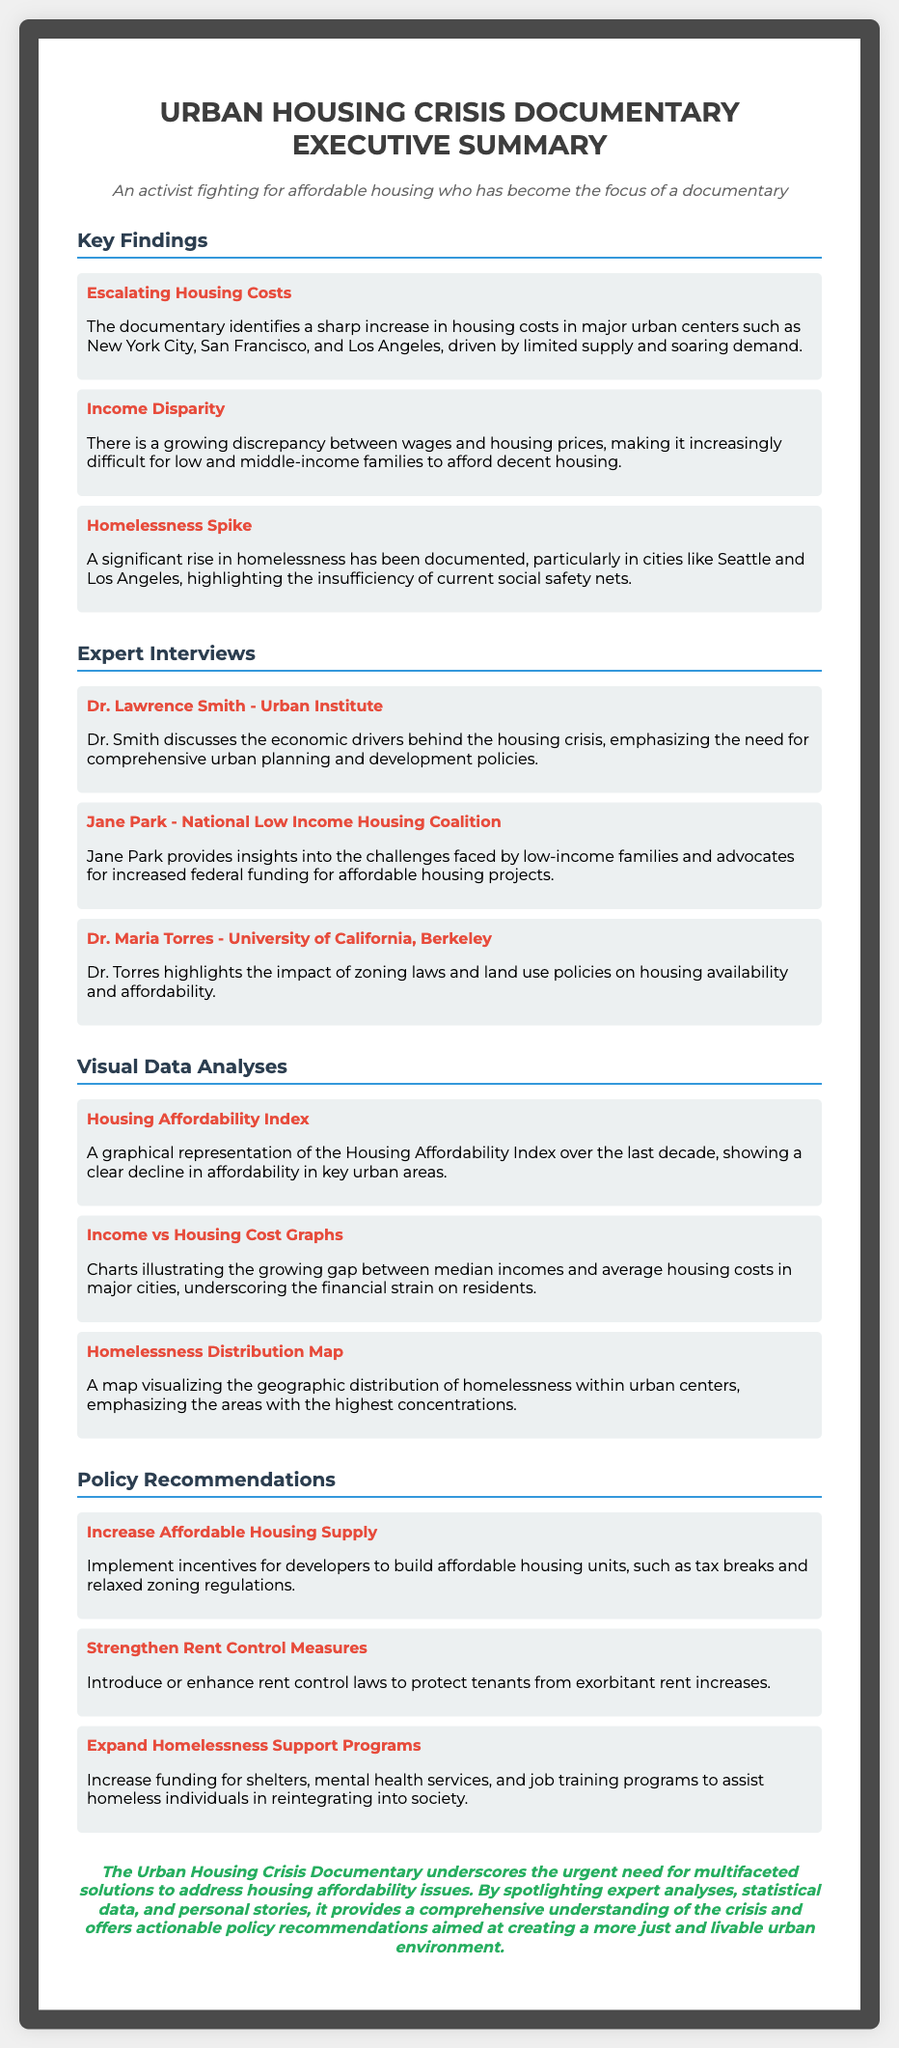what urban centers are identified for escalating housing costs? The document lists major urban centers where housing costs are escalating, specifically New York City, San Francisco, and Los Angeles.
Answer: New York City, San Francisco, Los Angeles who discusses the economic drivers behind the housing crisis? Dr. Lawrence Smith from the Urban Institute is mentioned as discussing the economic drivers behind the housing crisis in the documentary.
Answer: Dr. Lawrence Smith what is the main issue highlighted by Jane Park? Jane Park emphasizes the challenges faced by low-income families and advocates for increased federal funding for affordable housing projects.
Answer: Increased federal funding what visual data analysis shows the decline in affordability? The Housing Affordability Index is highlighted as a graphical representation showing a clear decline in affordability in key urban areas.
Answer: Housing Affordability Index what policy recommendation aims to protect tenants from rent increases? Strengthening rent control measures is a specific policy recommendation aimed at protecting tenants from exorbitant rent increases.
Answer: Strengthen rent control measures how has homelessness changed in cities like Seattle? The documentary indicates a significant rise in homelessness in cities like Seattle, emphasizing the inadequacy of current social safety nets.
Answer: Significant rise which expert comments on zoning laws? Dr. Maria Torres from the University of California, Berkeley discusses the impact of zoning laws on housing availability and affordability.
Answer: Dr. Maria Torres what year range does the visual data analysis cover? The Housing Affordability Index analysis covers the last decade.
Answer: Last decade 